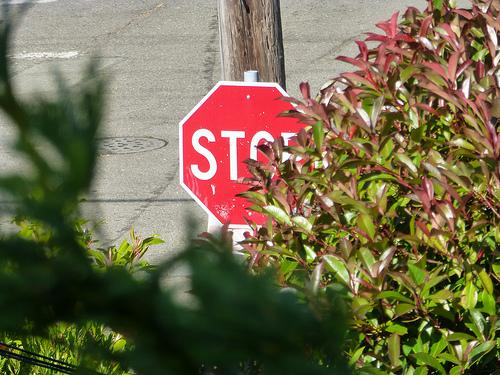How is the stop sign attached to the pole in the image, and what color is the pole? The stop sign is attached to the pole with a bolt, and the pole is brown in color. What can be inferred about the time of day when the image was captured? It is likely daytime, as indicated by the shadows and lighting in the image. What type of lines can be observed on the road, and what color are they? There are white markings, a yellow line, and a white stopping line on the road. What is hiding the stop sign partially in the image? The stop sign is partially hidden by green and auburn-colored bushes. What are the different markings present on the road in the image? The road has a white stopping line, a yellow line in the middle, and faded pedestrian crossing markings. What is the color and type of the sign in the image? The sign is a red and white stop sign. Describe the appearance of the bush in the image. The bush is green, blurry, and has leaves that are green, red, and pink. Mention one object on the road that is related to urban infrastructure. There is a manhole cover in the road. Can you describe the condition of the road in the image? The road is gray or grey in color, and has a manhole cover, white lines, and a yellow line in the middle. Identify the type of pole supporting the sign in the image. The pole supporting the sign is a wooden electric pole. 